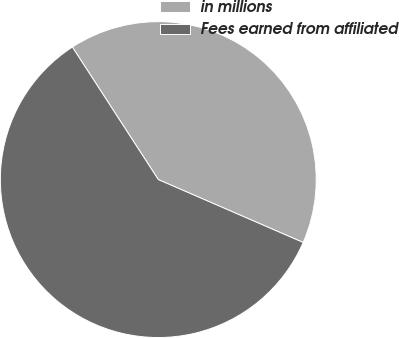<chart> <loc_0><loc_0><loc_500><loc_500><pie_chart><fcel>in millions<fcel>Fees earned from affiliated<nl><fcel>40.67%<fcel>59.33%<nl></chart> 